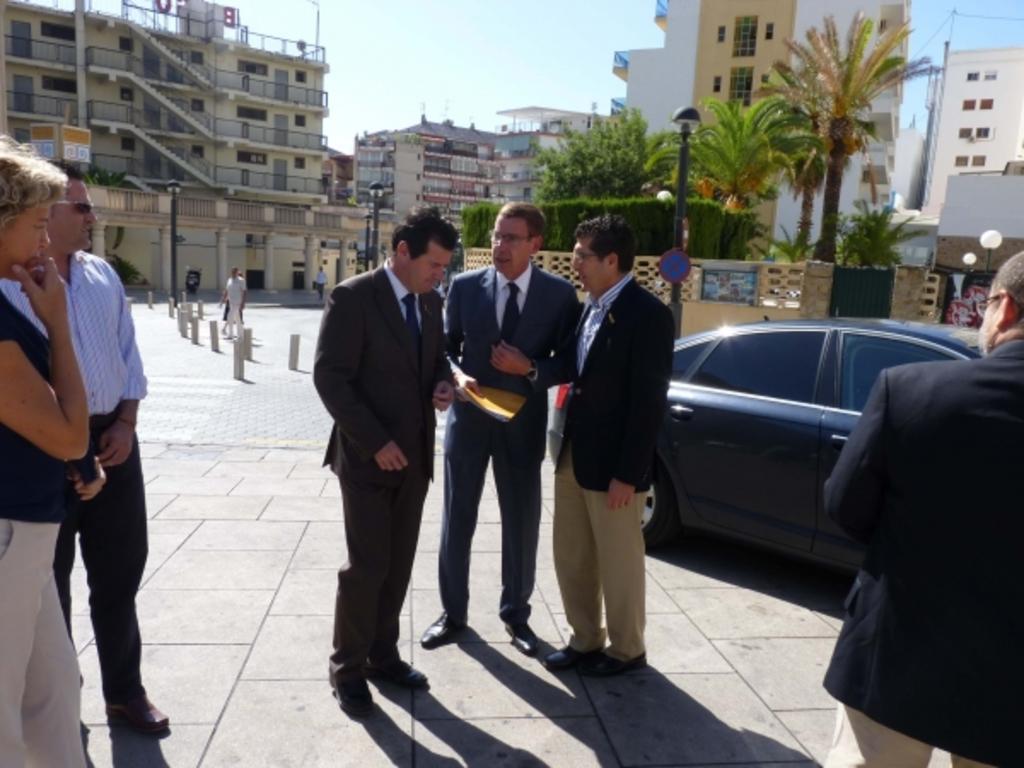Describe this image in one or two sentences. In this image we can see the persons standing on the path. In the background we can see the buildings, trees. We can also see the light poles and also the wall. There is a vehicle parked on the path. We can see some fencing rods on the road. Sky is also visible. 